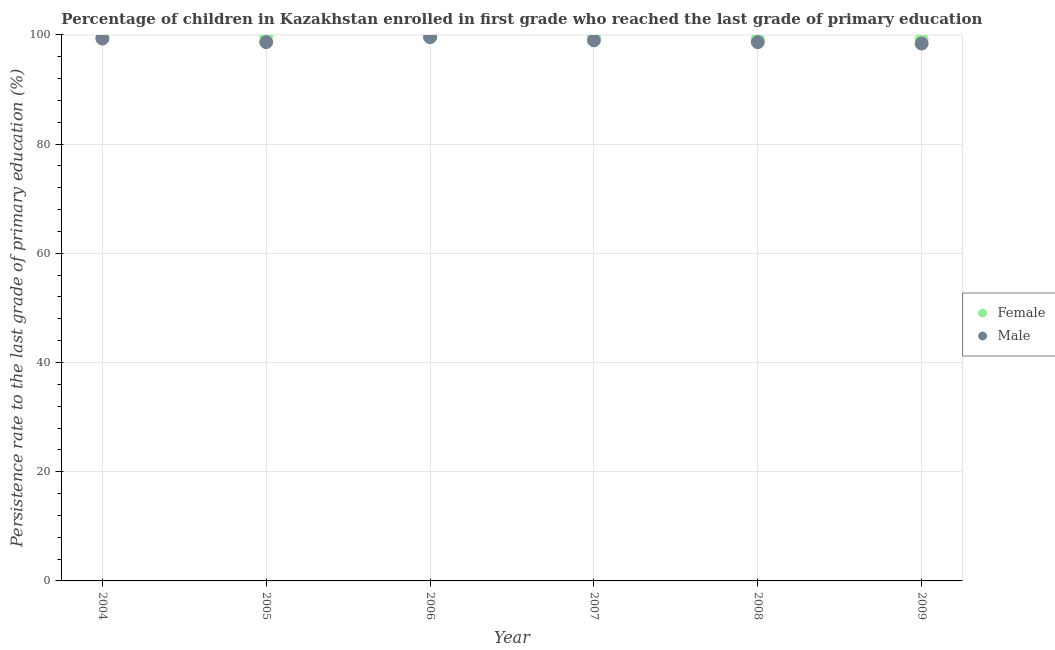Is the number of dotlines equal to the number of legend labels?
Keep it short and to the point. Yes. What is the persistence rate of female students in 2006?
Ensure brevity in your answer.  99.55. Across all years, what is the maximum persistence rate of male students?
Your answer should be compact. 99.6. Across all years, what is the minimum persistence rate of female students?
Keep it short and to the point. 99.15. In which year was the persistence rate of male students maximum?
Your answer should be very brief. 2006. In which year was the persistence rate of male students minimum?
Give a very brief answer. 2009. What is the total persistence rate of female students in the graph?
Keep it short and to the point. 597.32. What is the difference between the persistence rate of male students in 2006 and that in 2009?
Ensure brevity in your answer.  1.18. What is the difference between the persistence rate of male students in 2006 and the persistence rate of female students in 2009?
Keep it short and to the point. 0.46. What is the average persistence rate of female students per year?
Keep it short and to the point. 99.55. In the year 2006, what is the difference between the persistence rate of female students and persistence rate of male students?
Provide a succinct answer. -0.05. In how many years, is the persistence rate of female students greater than 48 %?
Your answer should be compact. 6. What is the ratio of the persistence rate of female students in 2004 to that in 2005?
Your answer should be compact. 1. Is the persistence rate of female students in 2004 less than that in 2005?
Keep it short and to the point. Yes. Is the difference between the persistence rate of female students in 2005 and 2006 greater than the difference between the persistence rate of male students in 2005 and 2006?
Provide a short and direct response. Yes. What is the difference between the highest and the second highest persistence rate of male students?
Give a very brief answer. 0.27. What is the difference between the highest and the lowest persistence rate of female students?
Your answer should be very brief. 0.78. Is the sum of the persistence rate of male students in 2005 and 2008 greater than the maximum persistence rate of female students across all years?
Provide a short and direct response. Yes. Does the persistence rate of male students monotonically increase over the years?
Offer a very short reply. No. Is the persistence rate of female students strictly greater than the persistence rate of male students over the years?
Provide a succinct answer. No. Is the persistence rate of male students strictly less than the persistence rate of female students over the years?
Provide a succinct answer. No. How many years are there in the graph?
Provide a short and direct response. 6. What is the difference between two consecutive major ticks on the Y-axis?
Offer a very short reply. 20. Are the values on the major ticks of Y-axis written in scientific E-notation?
Your response must be concise. No. Where does the legend appear in the graph?
Offer a terse response. Center right. How many legend labels are there?
Your answer should be compact. 2. What is the title of the graph?
Provide a short and direct response. Percentage of children in Kazakhstan enrolled in first grade who reached the last grade of primary education. Does "Primary school" appear as one of the legend labels in the graph?
Keep it short and to the point. No. What is the label or title of the Y-axis?
Ensure brevity in your answer.  Persistence rate to the last grade of primary education (%). What is the Persistence rate to the last grade of primary education (%) of Female in 2004?
Offer a very short reply. 99.55. What is the Persistence rate to the last grade of primary education (%) in Male in 2004?
Offer a very short reply. 99.34. What is the Persistence rate to the last grade of primary education (%) of Female in 2005?
Your answer should be very brief. 99.9. What is the Persistence rate to the last grade of primary education (%) in Male in 2005?
Give a very brief answer. 98.67. What is the Persistence rate to the last grade of primary education (%) in Female in 2006?
Ensure brevity in your answer.  99.55. What is the Persistence rate to the last grade of primary education (%) of Male in 2006?
Your response must be concise. 99.6. What is the Persistence rate to the last grade of primary education (%) in Female in 2007?
Ensure brevity in your answer.  99.93. What is the Persistence rate to the last grade of primary education (%) of Male in 2007?
Offer a terse response. 99. What is the Persistence rate to the last grade of primary education (%) in Female in 2008?
Your response must be concise. 99.24. What is the Persistence rate to the last grade of primary education (%) of Male in 2008?
Your answer should be compact. 98.67. What is the Persistence rate to the last grade of primary education (%) in Female in 2009?
Offer a terse response. 99.15. What is the Persistence rate to the last grade of primary education (%) in Male in 2009?
Your answer should be very brief. 98.42. Across all years, what is the maximum Persistence rate to the last grade of primary education (%) in Female?
Your answer should be very brief. 99.93. Across all years, what is the maximum Persistence rate to the last grade of primary education (%) of Male?
Provide a short and direct response. 99.6. Across all years, what is the minimum Persistence rate to the last grade of primary education (%) in Female?
Your answer should be compact. 99.15. Across all years, what is the minimum Persistence rate to the last grade of primary education (%) of Male?
Make the answer very short. 98.42. What is the total Persistence rate to the last grade of primary education (%) in Female in the graph?
Your answer should be compact. 597.32. What is the total Persistence rate to the last grade of primary education (%) in Male in the graph?
Offer a very short reply. 593.71. What is the difference between the Persistence rate to the last grade of primary education (%) of Female in 2004 and that in 2005?
Make the answer very short. -0.35. What is the difference between the Persistence rate to the last grade of primary education (%) of Male in 2004 and that in 2005?
Provide a short and direct response. 0.66. What is the difference between the Persistence rate to the last grade of primary education (%) of Female in 2004 and that in 2006?
Ensure brevity in your answer.  -0. What is the difference between the Persistence rate to the last grade of primary education (%) in Male in 2004 and that in 2006?
Your response must be concise. -0.27. What is the difference between the Persistence rate to the last grade of primary education (%) of Female in 2004 and that in 2007?
Ensure brevity in your answer.  -0.38. What is the difference between the Persistence rate to the last grade of primary education (%) of Male in 2004 and that in 2007?
Your answer should be very brief. 0.34. What is the difference between the Persistence rate to the last grade of primary education (%) of Female in 2004 and that in 2008?
Give a very brief answer. 0.31. What is the difference between the Persistence rate to the last grade of primary education (%) in Male in 2004 and that in 2008?
Ensure brevity in your answer.  0.67. What is the difference between the Persistence rate to the last grade of primary education (%) of Female in 2004 and that in 2009?
Keep it short and to the point. 0.4. What is the difference between the Persistence rate to the last grade of primary education (%) of Male in 2004 and that in 2009?
Provide a short and direct response. 0.91. What is the difference between the Persistence rate to the last grade of primary education (%) in Female in 2005 and that in 2006?
Provide a succinct answer. 0.35. What is the difference between the Persistence rate to the last grade of primary education (%) of Male in 2005 and that in 2006?
Your answer should be very brief. -0.93. What is the difference between the Persistence rate to the last grade of primary education (%) of Female in 2005 and that in 2007?
Ensure brevity in your answer.  -0.03. What is the difference between the Persistence rate to the last grade of primary education (%) of Male in 2005 and that in 2007?
Give a very brief answer. -0.33. What is the difference between the Persistence rate to the last grade of primary education (%) of Female in 2005 and that in 2008?
Provide a succinct answer. 0.66. What is the difference between the Persistence rate to the last grade of primary education (%) of Male in 2005 and that in 2008?
Your answer should be very brief. 0. What is the difference between the Persistence rate to the last grade of primary education (%) in Female in 2005 and that in 2009?
Give a very brief answer. 0.75. What is the difference between the Persistence rate to the last grade of primary education (%) in Male in 2005 and that in 2009?
Make the answer very short. 0.25. What is the difference between the Persistence rate to the last grade of primary education (%) of Female in 2006 and that in 2007?
Give a very brief answer. -0.38. What is the difference between the Persistence rate to the last grade of primary education (%) of Male in 2006 and that in 2007?
Offer a terse response. 0.6. What is the difference between the Persistence rate to the last grade of primary education (%) of Female in 2006 and that in 2008?
Your response must be concise. 0.31. What is the difference between the Persistence rate to the last grade of primary education (%) in Male in 2006 and that in 2008?
Your answer should be compact. 0.93. What is the difference between the Persistence rate to the last grade of primary education (%) in Female in 2006 and that in 2009?
Make the answer very short. 0.4. What is the difference between the Persistence rate to the last grade of primary education (%) in Male in 2006 and that in 2009?
Your response must be concise. 1.18. What is the difference between the Persistence rate to the last grade of primary education (%) of Female in 2007 and that in 2008?
Offer a terse response. 0.69. What is the difference between the Persistence rate to the last grade of primary education (%) of Male in 2007 and that in 2008?
Give a very brief answer. 0.33. What is the difference between the Persistence rate to the last grade of primary education (%) in Female in 2007 and that in 2009?
Provide a succinct answer. 0.78. What is the difference between the Persistence rate to the last grade of primary education (%) in Male in 2007 and that in 2009?
Your answer should be compact. 0.57. What is the difference between the Persistence rate to the last grade of primary education (%) of Female in 2008 and that in 2009?
Keep it short and to the point. 0.09. What is the difference between the Persistence rate to the last grade of primary education (%) of Male in 2008 and that in 2009?
Make the answer very short. 0.25. What is the difference between the Persistence rate to the last grade of primary education (%) of Female in 2004 and the Persistence rate to the last grade of primary education (%) of Male in 2005?
Provide a succinct answer. 0.88. What is the difference between the Persistence rate to the last grade of primary education (%) of Female in 2004 and the Persistence rate to the last grade of primary education (%) of Male in 2006?
Offer a terse response. -0.05. What is the difference between the Persistence rate to the last grade of primary education (%) of Female in 2004 and the Persistence rate to the last grade of primary education (%) of Male in 2007?
Keep it short and to the point. 0.55. What is the difference between the Persistence rate to the last grade of primary education (%) of Female in 2004 and the Persistence rate to the last grade of primary education (%) of Male in 2008?
Keep it short and to the point. 0.88. What is the difference between the Persistence rate to the last grade of primary education (%) in Female in 2004 and the Persistence rate to the last grade of primary education (%) in Male in 2009?
Your response must be concise. 1.13. What is the difference between the Persistence rate to the last grade of primary education (%) of Female in 2005 and the Persistence rate to the last grade of primary education (%) of Male in 2006?
Keep it short and to the point. 0.3. What is the difference between the Persistence rate to the last grade of primary education (%) of Female in 2005 and the Persistence rate to the last grade of primary education (%) of Male in 2007?
Your answer should be compact. 0.9. What is the difference between the Persistence rate to the last grade of primary education (%) of Female in 2005 and the Persistence rate to the last grade of primary education (%) of Male in 2008?
Your response must be concise. 1.23. What is the difference between the Persistence rate to the last grade of primary education (%) in Female in 2005 and the Persistence rate to the last grade of primary education (%) in Male in 2009?
Ensure brevity in your answer.  1.47. What is the difference between the Persistence rate to the last grade of primary education (%) of Female in 2006 and the Persistence rate to the last grade of primary education (%) of Male in 2007?
Provide a short and direct response. 0.55. What is the difference between the Persistence rate to the last grade of primary education (%) of Female in 2006 and the Persistence rate to the last grade of primary education (%) of Male in 2008?
Give a very brief answer. 0.88. What is the difference between the Persistence rate to the last grade of primary education (%) in Female in 2006 and the Persistence rate to the last grade of primary education (%) in Male in 2009?
Make the answer very short. 1.13. What is the difference between the Persistence rate to the last grade of primary education (%) in Female in 2007 and the Persistence rate to the last grade of primary education (%) in Male in 2008?
Your answer should be compact. 1.26. What is the difference between the Persistence rate to the last grade of primary education (%) of Female in 2007 and the Persistence rate to the last grade of primary education (%) of Male in 2009?
Ensure brevity in your answer.  1.51. What is the difference between the Persistence rate to the last grade of primary education (%) of Female in 2008 and the Persistence rate to the last grade of primary education (%) of Male in 2009?
Offer a very short reply. 0.82. What is the average Persistence rate to the last grade of primary education (%) in Female per year?
Your response must be concise. 99.55. What is the average Persistence rate to the last grade of primary education (%) of Male per year?
Your answer should be compact. 98.95. In the year 2004, what is the difference between the Persistence rate to the last grade of primary education (%) in Female and Persistence rate to the last grade of primary education (%) in Male?
Offer a terse response. 0.21. In the year 2005, what is the difference between the Persistence rate to the last grade of primary education (%) in Female and Persistence rate to the last grade of primary education (%) in Male?
Provide a succinct answer. 1.23. In the year 2006, what is the difference between the Persistence rate to the last grade of primary education (%) of Female and Persistence rate to the last grade of primary education (%) of Male?
Offer a terse response. -0.05. In the year 2007, what is the difference between the Persistence rate to the last grade of primary education (%) in Female and Persistence rate to the last grade of primary education (%) in Male?
Offer a terse response. 0.93. In the year 2008, what is the difference between the Persistence rate to the last grade of primary education (%) in Female and Persistence rate to the last grade of primary education (%) in Male?
Your answer should be compact. 0.57. In the year 2009, what is the difference between the Persistence rate to the last grade of primary education (%) in Female and Persistence rate to the last grade of primary education (%) in Male?
Your answer should be compact. 0.72. What is the ratio of the Persistence rate to the last grade of primary education (%) in Male in 2004 to that in 2005?
Your answer should be compact. 1.01. What is the ratio of the Persistence rate to the last grade of primary education (%) in Female in 2004 to that in 2006?
Provide a short and direct response. 1. What is the ratio of the Persistence rate to the last grade of primary education (%) in Male in 2004 to that in 2006?
Offer a terse response. 1. What is the ratio of the Persistence rate to the last grade of primary education (%) of Female in 2004 to that in 2007?
Give a very brief answer. 1. What is the ratio of the Persistence rate to the last grade of primary education (%) in Male in 2004 to that in 2008?
Your response must be concise. 1.01. What is the ratio of the Persistence rate to the last grade of primary education (%) of Female in 2004 to that in 2009?
Offer a very short reply. 1. What is the ratio of the Persistence rate to the last grade of primary education (%) in Male in 2004 to that in 2009?
Provide a short and direct response. 1.01. What is the ratio of the Persistence rate to the last grade of primary education (%) in Female in 2005 to that in 2007?
Keep it short and to the point. 1. What is the ratio of the Persistence rate to the last grade of primary education (%) of Male in 2005 to that in 2007?
Ensure brevity in your answer.  1. What is the ratio of the Persistence rate to the last grade of primary education (%) in Female in 2005 to that in 2008?
Keep it short and to the point. 1.01. What is the ratio of the Persistence rate to the last grade of primary education (%) of Male in 2005 to that in 2008?
Offer a very short reply. 1. What is the ratio of the Persistence rate to the last grade of primary education (%) of Female in 2005 to that in 2009?
Ensure brevity in your answer.  1.01. What is the ratio of the Persistence rate to the last grade of primary education (%) in Male in 2005 to that in 2009?
Your answer should be very brief. 1. What is the ratio of the Persistence rate to the last grade of primary education (%) of Female in 2006 to that in 2007?
Offer a very short reply. 1. What is the ratio of the Persistence rate to the last grade of primary education (%) in Male in 2006 to that in 2008?
Provide a short and direct response. 1.01. What is the ratio of the Persistence rate to the last grade of primary education (%) in Female in 2006 to that in 2009?
Give a very brief answer. 1. What is the ratio of the Persistence rate to the last grade of primary education (%) in Male in 2007 to that in 2008?
Give a very brief answer. 1. What is the ratio of the Persistence rate to the last grade of primary education (%) in Female in 2007 to that in 2009?
Keep it short and to the point. 1.01. What is the ratio of the Persistence rate to the last grade of primary education (%) of Male in 2007 to that in 2009?
Your response must be concise. 1.01. What is the ratio of the Persistence rate to the last grade of primary education (%) of Male in 2008 to that in 2009?
Make the answer very short. 1. What is the difference between the highest and the second highest Persistence rate to the last grade of primary education (%) in Female?
Provide a succinct answer. 0.03. What is the difference between the highest and the second highest Persistence rate to the last grade of primary education (%) of Male?
Your answer should be compact. 0.27. What is the difference between the highest and the lowest Persistence rate to the last grade of primary education (%) in Female?
Keep it short and to the point. 0.78. What is the difference between the highest and the lowest Persistence rate to the last grade of primary education (%) in Male?
Your response must be concise. 1.18. 